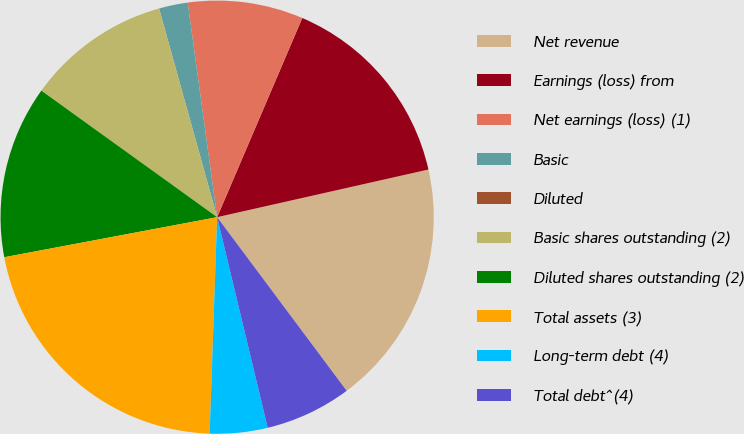Convert chart to OTSL. <chart><loc_0><loc_0><loc_500><loc_500><pie_chart><fcel>Net revenue<fcel>Earnings (loss) from<fcel>Net earnings (loss) (1)<fcel>Basic<fcel>Diluted<fcel>Basic shares outstanding (2)<fcel>Diluted shares outstanding (2)<fcel>Total assets (3)<fcel>Long-term debt (4)<fcel>Total debt^(4)<nl><fcel>18.33%<fcel>15.04%<fcel>8.6%<fcel>2.15%<fcel>0.0%<fcel>10.75%<fcel>12.89%<fcel>21.49%<fcel>4.3%<fcel>6.45%<nl></chart> 